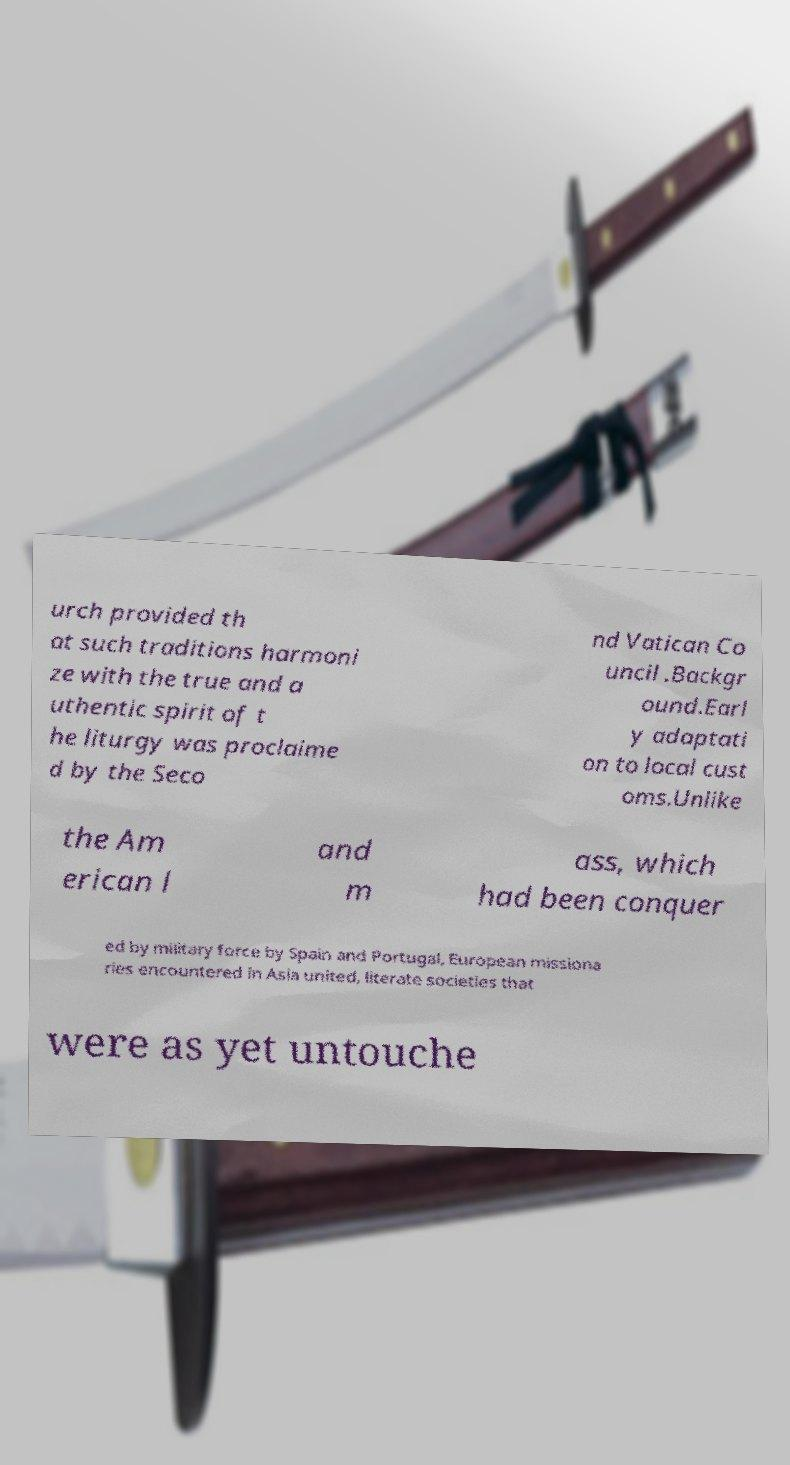I need the written content from this picture converted into text. Can you do that? urch provided th at such traditions harmoni ze with the true and a uthentic spirit of t he liturgy was proclaime d by the Seco nd Vatican Co uncil .Backgr ound.Earl y adaptati on to local cust oms.Unlike the Am erican l and m ass, which had been conquer ed by military force by Spain and Portugal, European missiona ries encountered in Asia united, literate societies that were as yet untouche 